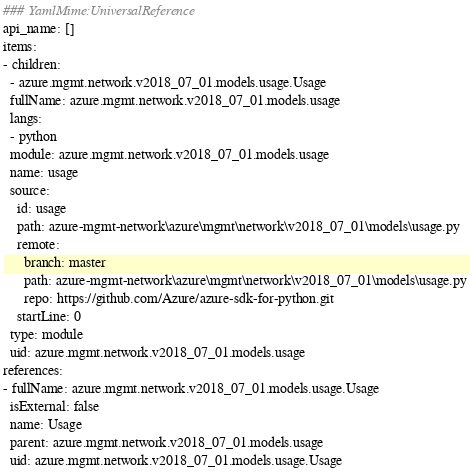Convert code to text. <code><loc_0><loc_0><loc_500><loc_500><_YAML_>### YamlMime:UniversalReference
api_name: []
items:
- children:
  - azure.mgmt.network.v2018_07_01.models.usage.Usage
  fullName: azure.mgmt.network.v2018_07_01.models.usage
  langs:
  - python
  module: azure.mgmt.network.v2018_07_01.models.usage
  name: usage
  source:
    id: usage
    path: azure-mgmt-network\azure\mgmt\network\v2018_07_01\models\usage.py
    remote:
      branch: master
      path: azure-mgmt-network\azure\mgmt\network\v2018_07_01\models\usage.py
      repo: https://github.com/Azure/azure-sdk-for-python.git
    startLine: 0
  type: module
  uid: azure.mgmt.network.v2018_07_01.models.usage
references:
- fullName: azure.mgmt.network.v2018_07_01.models.usage.Usage
  isExternal: false
  name: Usage
  parent: azure.mgmt.network.v2018_07_01.models.usage
  uid: azure.mgmt.network.v2018_07_01.models.usage.Usage
</code> 